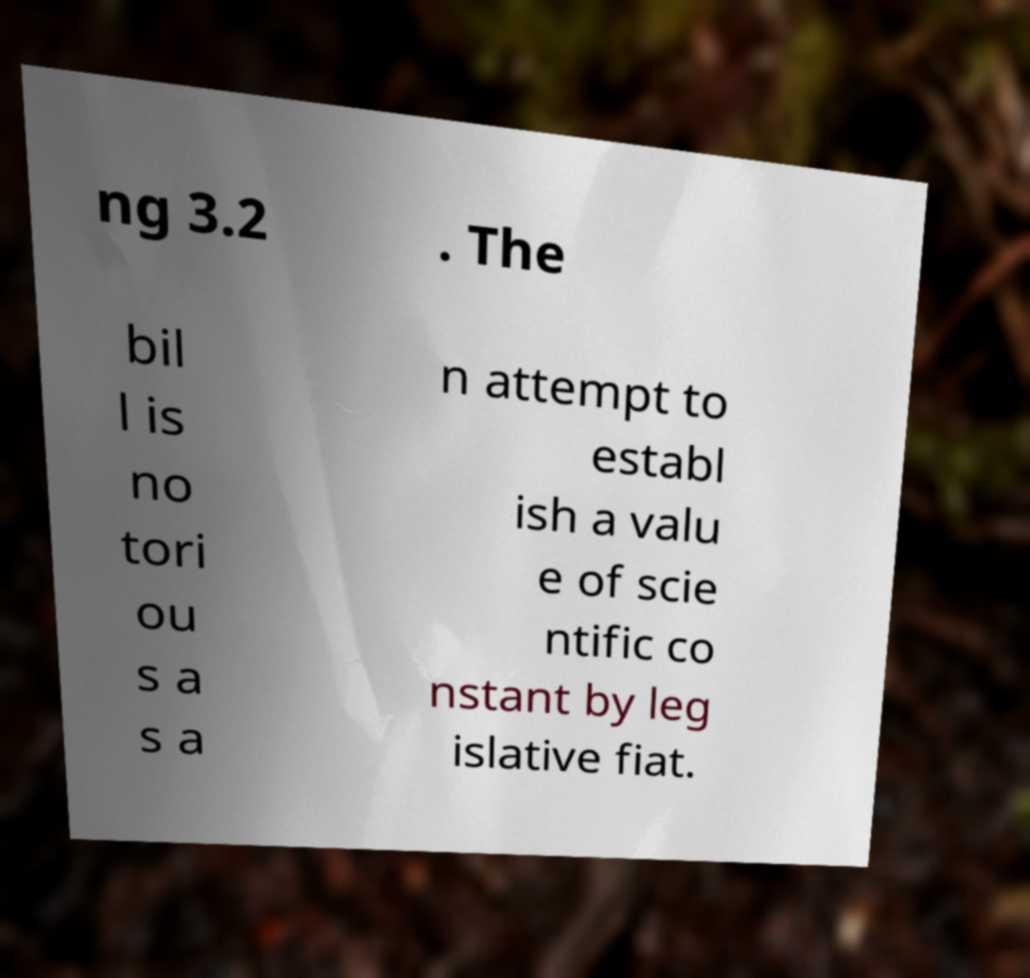Could you extract and type out the text from this image? ng 3.2 . The bil l is no tori ou s a s a n attempt to establ ish a valu e of scie ntific co nstant by leg islative fiat. 